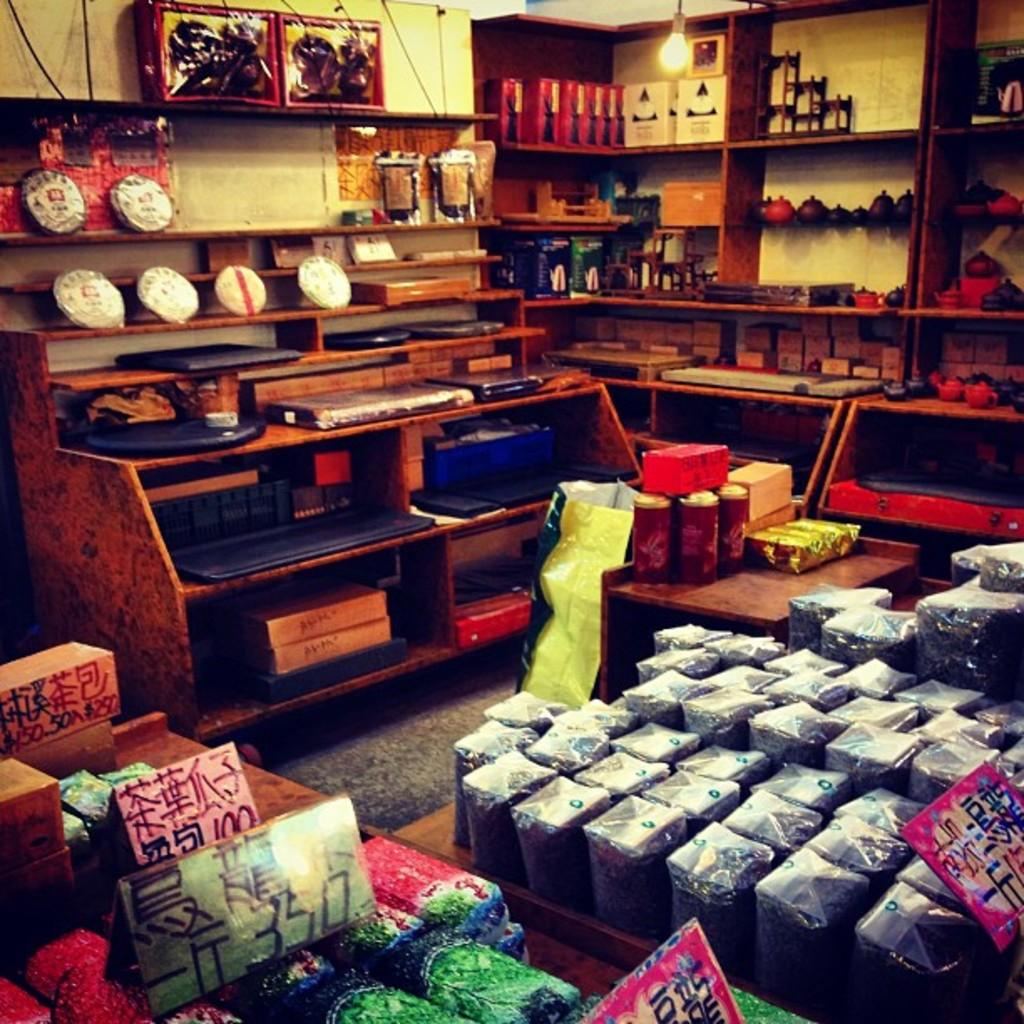Provide a one-sentence caption for the provided image. Store products in display bins with a rectangle green sign with 350 in black letters. 